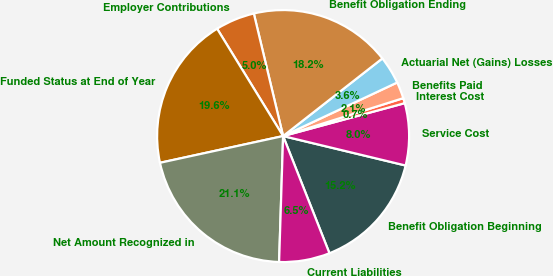Convert chart to OTSL. <chart><loc_0><loc_0><loc_500><loc_500><pie_chart><fcel>Benefit Obligation Beginning<fcel>Service Cost<fcel>Interest Cost<fcel>Benefits Paid<fcel>Actuarial Net (Gains) Losses<fcel>Benefit Obligation Ending<fcel>Employer Contributions<fcel>Funded Status at End of Year<fcel>Net Amount Recognized in<fcel>Current Liabilities<nl><fcel>15.25%<fcel>7.96%<fcel>0.66%<fcel>2.12%<fcel>3.58%<fcel>18.17%<fcel>5.04%<fcel>19.63%<fcel>21.09%<fcel>6.5%<nl></chart> 